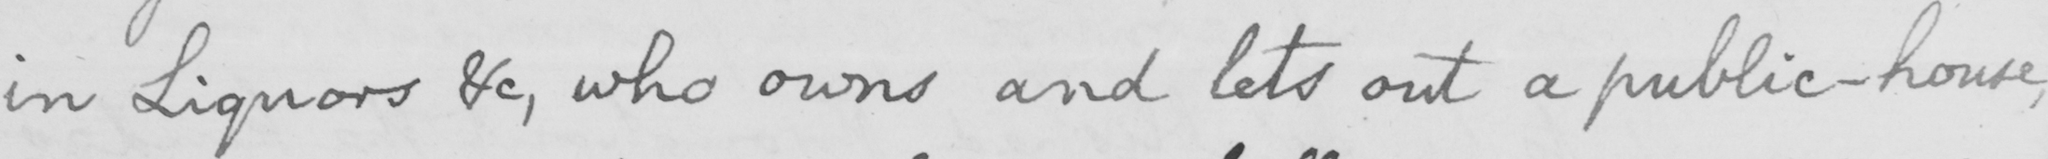Can you read and transcribe this handwriting? in Liquors &c , who owns and lets out a public-house , 